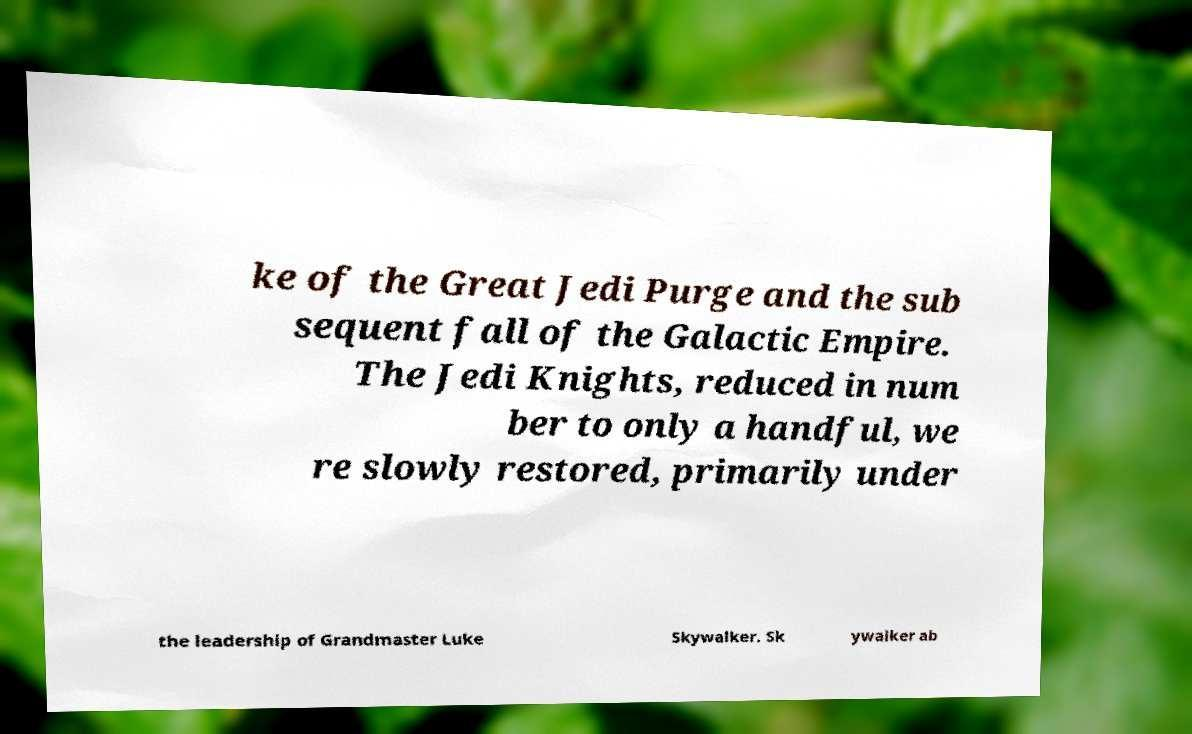Please read and relay the text visible in this image. What does it say? ke of the Great Jedi Purge and the sub sequent fall of the Galactic Empire. The Jedi Knights, reduced in num ber to only a handful, we re slowly restored, primarily under the leadership of Grandmaster Luke Skywalker. Sk ywalker ab 